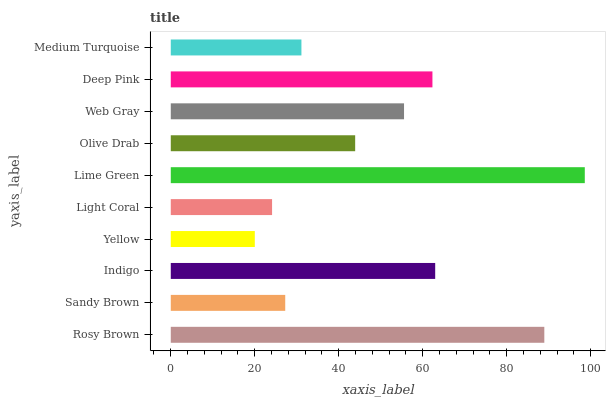Is Yellow the minimum?
Answer yes or no. Yes. Is Lime Green the maximum?
Answer yes or no. Yes. Is Sandy Brown the minimum?
Answer yes or no. No. Is Sandy Brown the maximum?
Answer yes or no. No. Is Rosy Brown greater than Sandy Brown?
Answer yes or no. Yes. Is Sandy Brown less than Rosy Brown?
Answer yes or no. Yes. Is Sandy Brown greater than Rosy Brown?
Answer yes or no. No. Is Rosy Brown less than Sandy Brown?
Answer yes or no. No. Is Web Gray the high median?
Answer yes or no. Yes. Is Olive Drab the low median?
Answer yes or no. Yes. Is Yellow the high median?
Answer yes or no. No. Is Rosy Brown the low median?
Answer yes or no. No. 